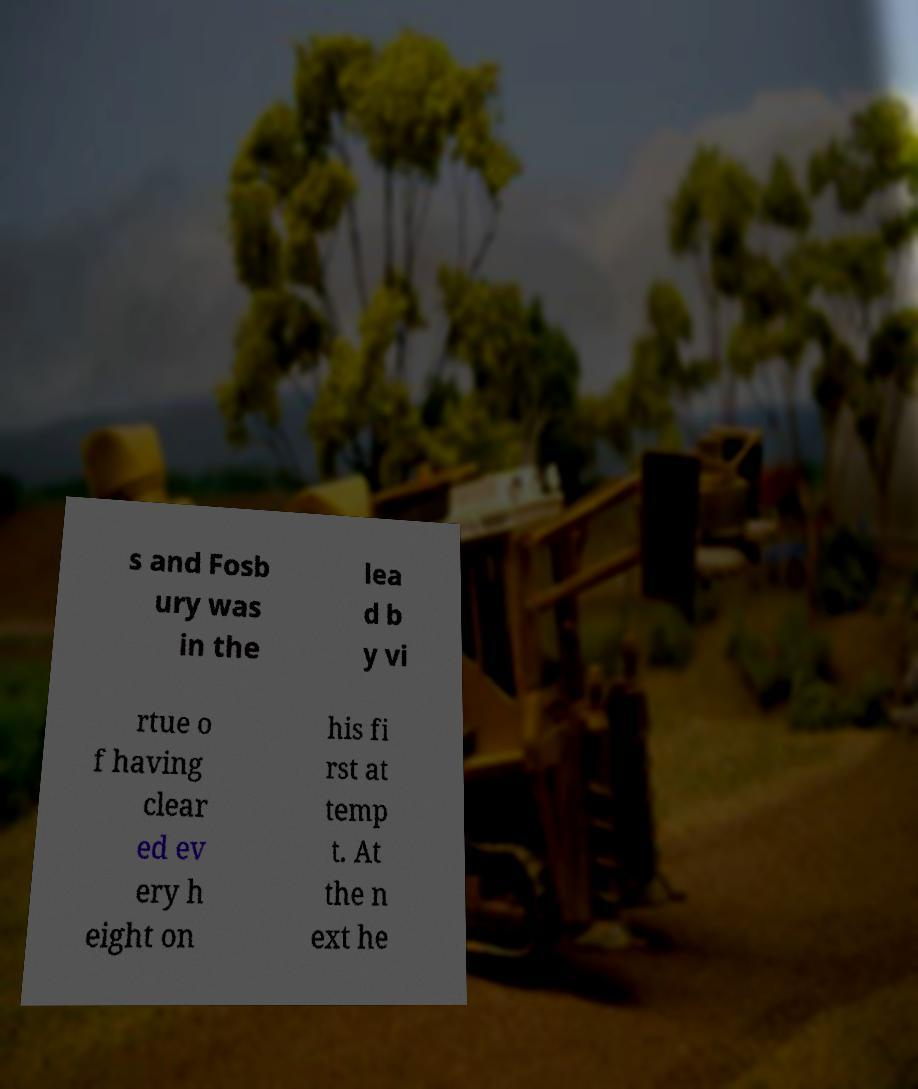Please identify and transcribe the text found in this image. s and Fosb ury was in the lea d b y vi rtue o f having clear ed ev ery h eight on his fi rst at temp t. At the n ext he 